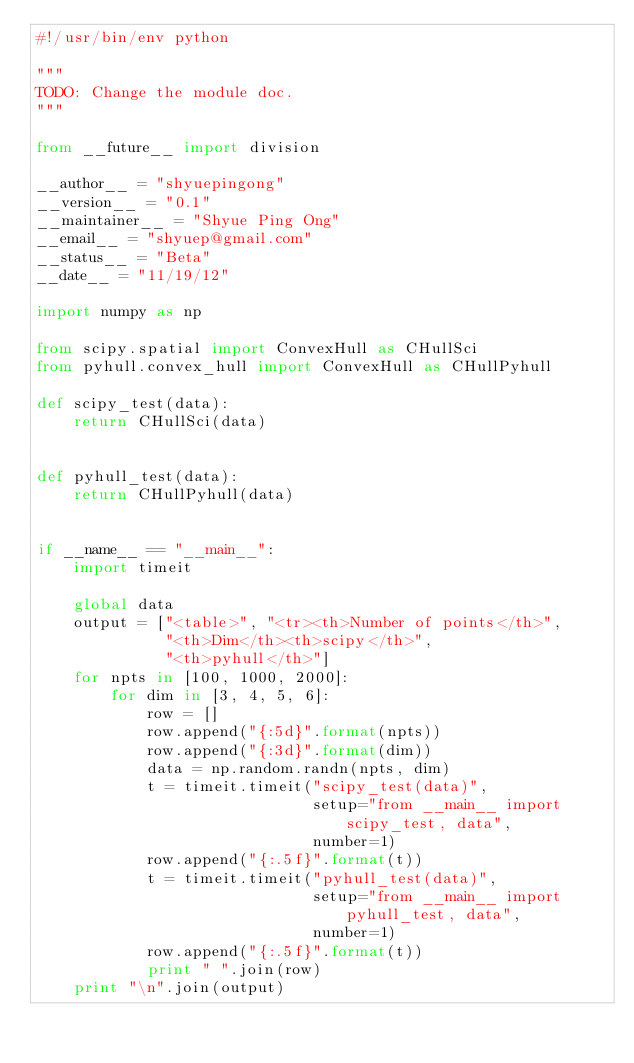<code> <loc_0><loc_0><loc_500><loc_500><_Python_>#!/usr/bin/env python

"""
TODO: Change the module doc.
"""

from __future__ import division

__author__ = "shyuepingong"
__version__ = "0.1"
__maintainer__ = "Shyue Ping Ong"
__email__ = "shyuep@gmail.com"
__status__ = "Beta"
__date__ = "11/19/12"

import numpy as np

from scipy.spatial import ConvexHull as CHullSci
from pyhull.convex_hull import ConvexHull as CHullPyhull

def scipy_test(data):
    return CHullSci(data)


def pyhull_test(data):
    return CHullPyhull(data)


if __name__ == "__main__":
    import timeit

    global data
    output = ["<table>", "<tr><th>Number of points</th>",
              "<th>Dim</th><th>scipy</th>",
              "<th>pyhull</th>"]
    for npts in [100, 1000, 2000]:
        for dim in [3, 4, 5, 6]:
            row = []
            row.append("{:5d}".format(npts))
            row.append("{:3d}".format(dim))
            data = np.random.randn(npts, dim)
            t = timeit.timeit("scipy_test(data)",
                              setup="from __main__ import scipy_test, data",
                              number=1)
            row.append("{:.5f}".format(t))
            t = timeit.timeit("pyhull_test(data)",
                              setup="from __main__ import pyhull_test, data",
                              number=1)
            row.append("{:.5f}".format(t))
            print " ".join(row)
    print "\n".join(output)</code> 